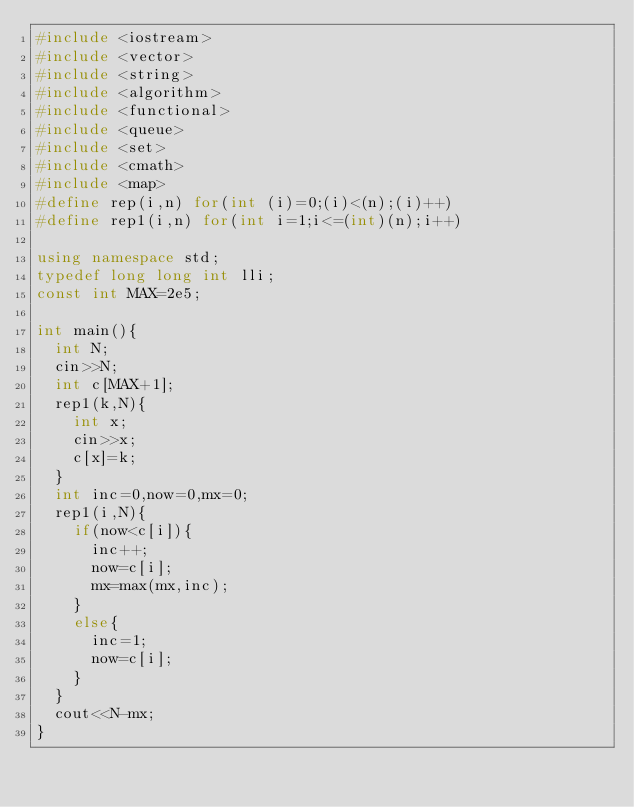<code> <loc_0><loc_0><loc_500><loc_500><_C++_>#include <iostream>
#include <vector>
#include <string>
#include <algorithm>
#include <functional>
#include <queue>
#include <set>
#include <cmath>
#include <map>
#define rep(i,n) for(int (i)=0;(i)<(n);(i)++)
#define rep1(i,n) for(int i=1;i<=(int)(n);i++)

using namespace std;
typedef long long int lli;
const int MAX=2e5;

int main(){
	int N;
	cin>>N;
	int c[MAX+1];
	rep1(k,N){
		int x;
		cin>>x;
		c[x]=k;
	}
	int inc=0,now=0,mx=0;
	rep1(i,N){
		if(now<c[i]){
			inc++;
			now=c[i];
			mx=max(mx,inc);
		}
		else{
			inc=1;
			now=c[i];
		}
	}
	cout<<N-mx;
}</code> 